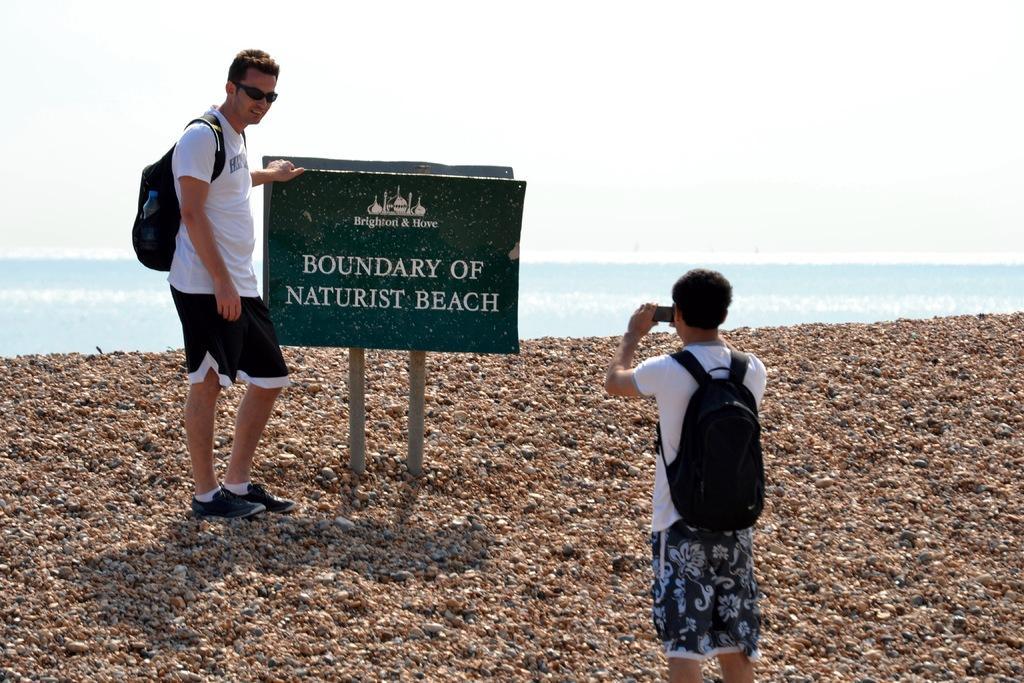Can you describe this image briefly? In this picture I can see 2 men standing in front and I see that both of them are wearing bags and the man on the right is holding an electronic device and the man on the left is near to a board and I see something is written on it. In the background I can see the sky and I can also see the water. 